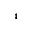Convert formula to latex. <formula><loc_0><loc_0><loc_500><loc_500>^ { 4 }</formula> 